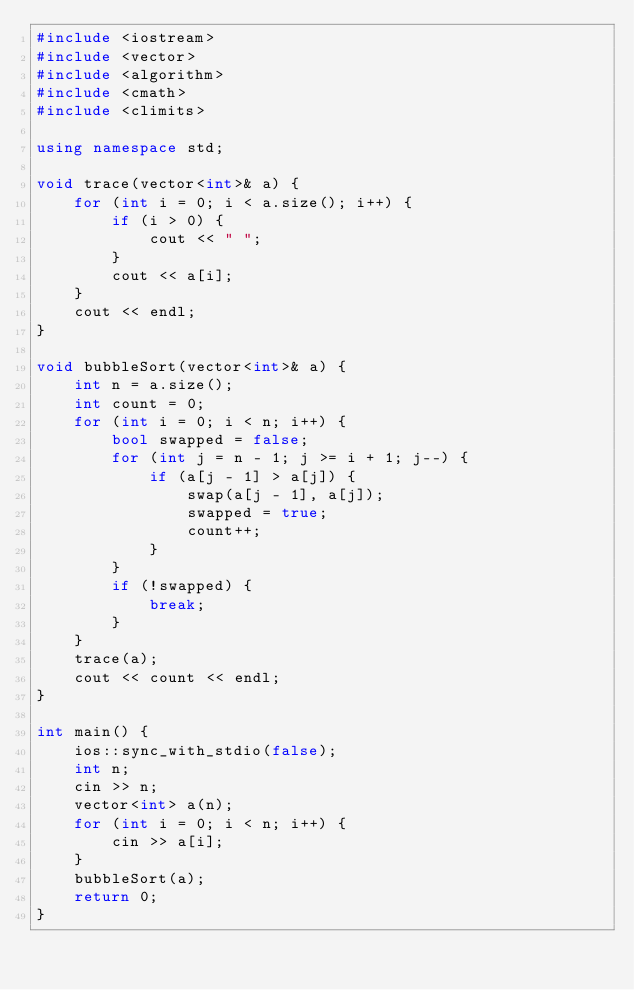<code> <loc_0><loc_0><loc_500><loc_500><_C++_>#include <iostream>
#include <vector>
#include <algorithm>
#include <cmath>
#include <climits>

using namespace std;

void trace(vector<int>& a) {
    for (int i = 0; i < a.size(); i++) {
        if (i > 0) {
            cout << " ";
        }
        cout << a[i];
    }
    cout << endl;
}

void bubbleSort(vector<int>& a) {
    int n = a.size();
    int count = 0;
    for (int i = 0; i < n; i++) {
        bool swapped = false;
        for (int j = n - 1; j >= i + 1; j--) {
            if (a[j - 1] > a[j]) {
                swap(a[j - 1], a[j]);
                swapped = true;
                count++;
            }
        }
        if (!swapped) {
            break;
        }
    }
    trace(a);
    cout << count << endl;
}

int main() {
    ios::sync_with_stdio(false);
    int n;
    cin >> n;
    vector<int> a(n);
    for (int i = 0; i < n; i++) {
        cin >> a[i];
    }
    bubbleSort(a);
    return 0;
}</code> 